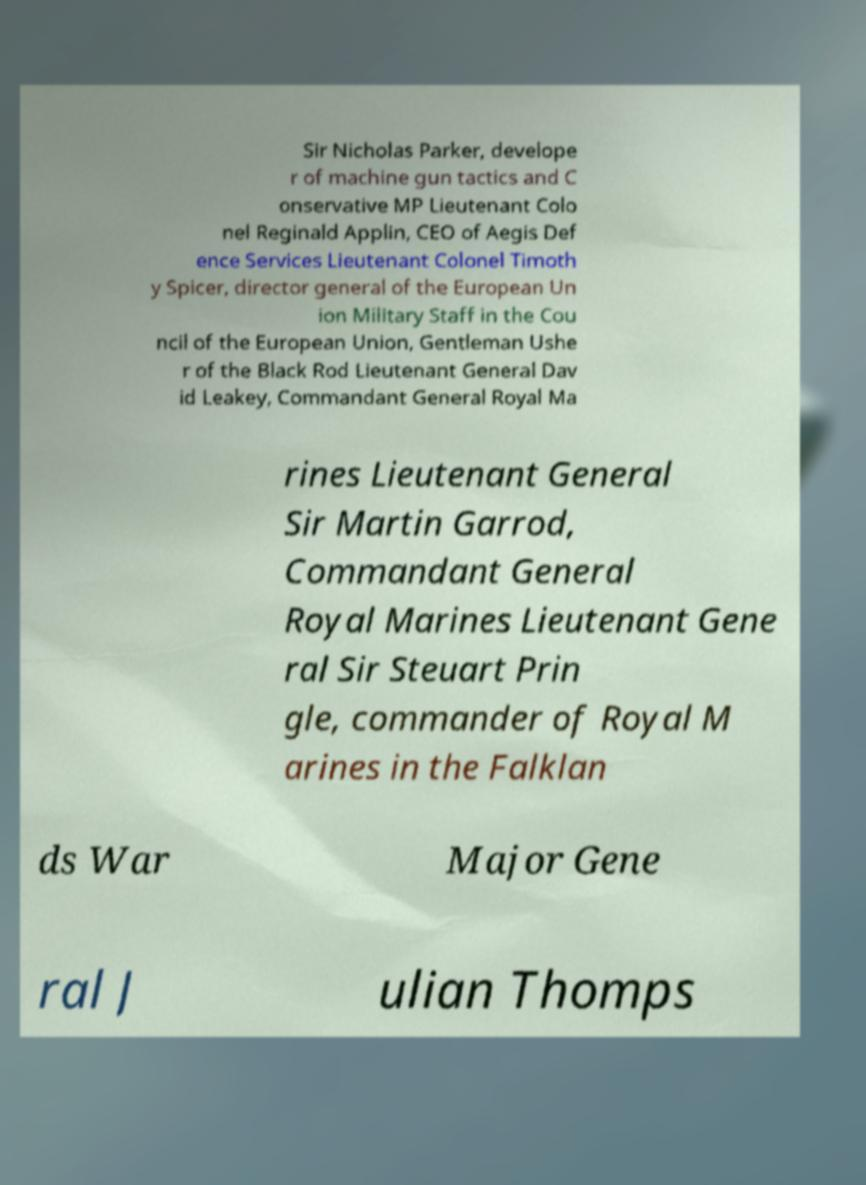Could you extract and type out the text from this image? Sir Nicholas Parker, develope r of machine gun tactics and C onservative MP Lieutenant Colo nel Reginald Applin, CEO of Aegis Def ence Services Lieutenant Colonel Timoth y Spicer, director general of the European Un ion Military Staff in the Cou ncil of the European Union, Gentleman Ushe r of the Black Rod Lieutenant General Dav id Leakey, Commandant General Royal Ma rines Lieutenant General Sir Martin Garrod, Commandant General Royal Marines Lieutenant Gene ral Sir Steuart Prin gle, commander of Royal M arines in the Falklan ds War Major Gene ral J ulian Thomps 